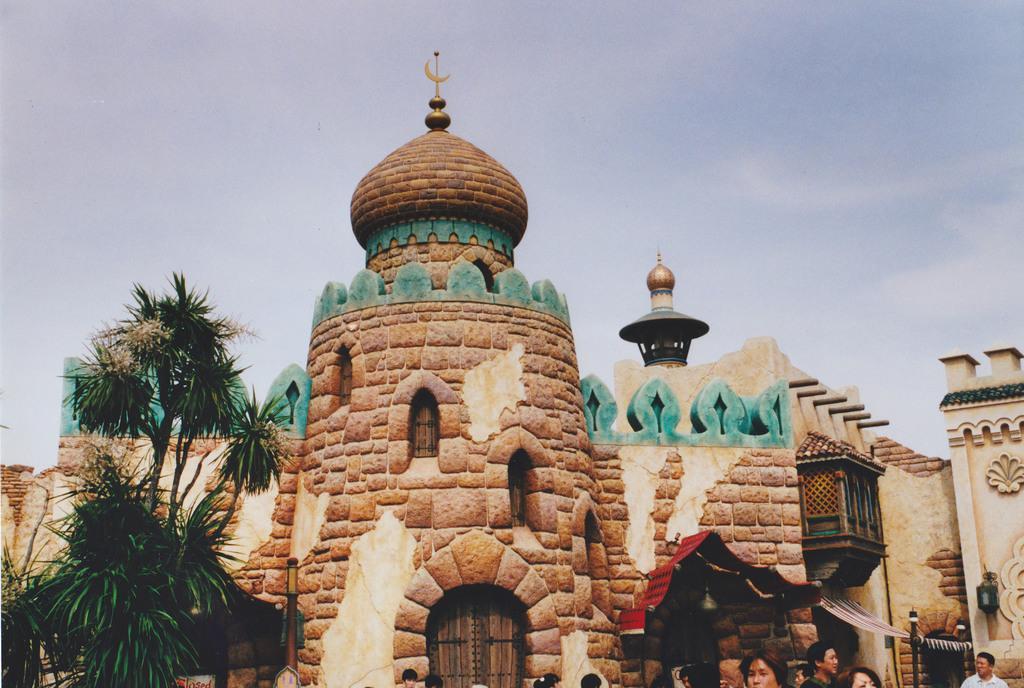How would you summarize this image in a sentence or two? In this image there is a castle in the middle. On the left side there are trees. At the top there is the sky. 